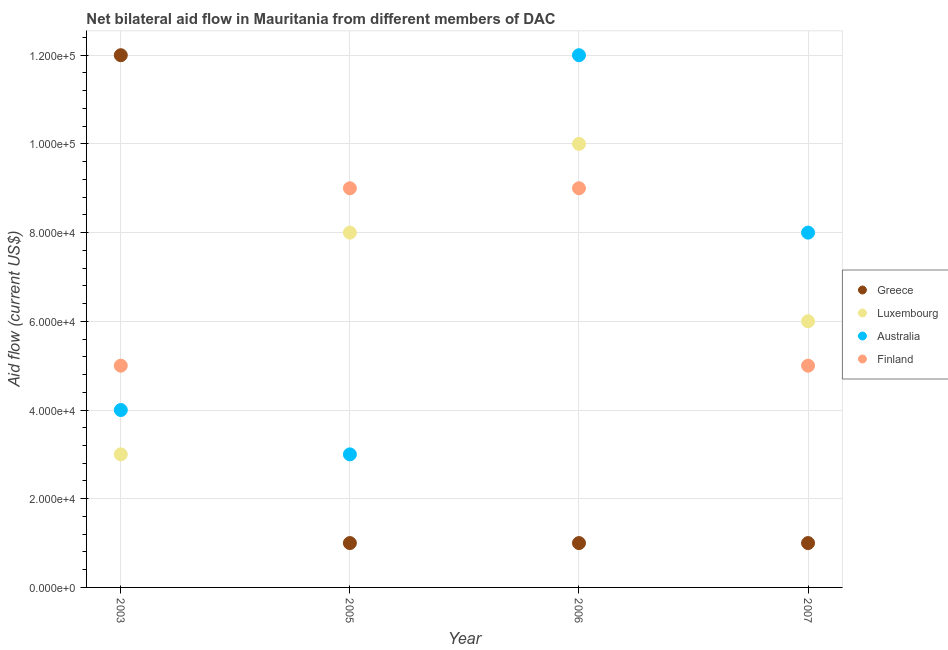How many different coloured dotlines are there?
Offer a terse response. 4. Is the number of dotlines equal to the number of legend labels?
Your response must be concise. Yes. What is the amount of aid given by australia in 2005?
Ensure brevity in your answer.  3.00e+04. Across all years, what is the maximum amount of aid given by finland?
Offer a very short reply. 9.00e+04. Across all years, what is the minimum amount of aid given by australia?
Your answer should be compact. 3.00e+04. In which year was the amount of aid given by australia maximum?
Your answer should be very brief. 2006. In which year was the amount of aid given by finland minimum?
Offer a terse response. 2003. What is the total amount of aid given by australia in the graph?
Offer a very short reply. 2.70e+05. What is the difference between the amount of aid given by finland in 2003 and that in 2005?
Provide a short and direct response. -4.00e+04. What is the difference between the amount of aid given by australia in 2003 and the amount of aid given by luxembourg in 2007?
Your response must be concise. -2.00e+04. What is the average amount of aid given by luxembourg per year?
Keep it short and to the point. 6.75e+04. In the year 2007, what is the difference between the amount of aid given by greece and amount of aid given by luxembourg?
Offer a very short reply. -5.00e+04. Is the difference between the amount of aid given by finland in 2003 and 2006 greater than the difference between the amount of aid given by australia in 2003 and 2006?
Your answer should be very brief. Yes. What is the difference between the highest and the lowest amount of aid given by finland?
Give a very brief answer. 4.00e+04. In how many years, is the amount of aid given by greece greater than the average amount of aid given by greece taken over all years?
Your response must be concise. 1. Is the sum of the amount of aid given by australia in 2003 and 2005 greater than the maximum amount of aid given by greece across all years?
Your answer should be very brief. No. Is it the case that in every year, the sum of the amount of aid given by greece and amount of aid given by luxembourg is greater than the amount of aid given by australia?
Your answer should be compact. No. Is the amount of aid given by greece strictly less than the amount of aid given by australia over the years?
Offer a terse response. No. How many dotlines are there?
Provide a short and direct response. 4. What is the difference between two consecutive major ticks on the Y-axis?
Offer a very short reply. 2.00e+04. How many legend labels are there?
Ensure brevity in your answer.  4. How are the legend labels stacked?
Your answer should be compact. Vertical. What is the title of the graph?
Keep it short and to the point. Net bilateral aid flow in Mauritania from different members of DAC. What is the label or title of the Y-axis?
Provide a succinct answer. Aid flow (current US$). What is the Aid flow (current US$) in Finland in 2003?
Give a very brief answer. 5.00e+04. What is the Aid flow (current US$) of Greece in 2005?
Your answer should be compact. 10000. What is the Aid flow (current US$) of Luxembourg in 2005?
Give a very brief answer. 8.00e+04. What is the Aid flow (current US$) in Australia in 2005?
Keep it short and to the point. 3.00e+04. What is the Aid flow (current US$) in Finland in 2005?
Ensure brevity in your answer.  9.00e+04. What is the Aid flow (current US$) of Greece in 2006?
Ensure brevity in your answer.  10000. What is the Aid flow (current US$) in Luxembourg in 2006?
Ensure brevity in your answer.  1.00e+05. What is the Aid flow (current US$) of Australia in 2006?
Your response must be concise. 1.20e+05. What is the Aid flow (current US$) of Finland in 2006?
Provide a short and direct response. 9.00e+04. What is the Aid flow (current US$) of Luxembourg in 2007?
Provide a succinct answer. 6.00e+04. What is the Aid flow (current US$) of Finland in 2007?
Your answer should be very brief. 5.00e+04. Across all years, what is the maximum Aid flow (current US$) in Luxembourg?
Ensure brevity in your answer.  1.00e+05. Across all years, what is the maximum Aid flow (current US$) of Australia?
Offer a very short reply. 1.20e+05. Across all years, what is the minimum Aid flow (current US$) in Greece?
Provide a succinct answer. 10000. Across all years, what is the minimum Aid flow (current US$) of Australia?
Provide a short and direct response. 3.00e+04. What is the total Aid flow (current US$) of Greece in the graph?
Your answer should be compact. 1.50e+05. What is the total Aid flow (current US$) of Luxembourg in the graph?
Make the answer very short. 2.70e+05. What is the total Aid flow (current US$) of Australia in the graph?
Keep it short and to the point. 2.70e+05. What is the difference between the Aid flow (current US$) of Greece in 2003 and that in 2005?
Offer a very short reply. 1.10e+05. What is the difference between the Aid flow (current US$) of Luxembourg in 2003 and that in 2005?
Keep it short and to the point. -5.00e+04. What is the difference between the Aid flow (current US$) in Australia in 2003 and that in 2005?
Keep it short and to the point. 10000. What is the difference between the Aid flow (current US$) of Finland in 2003 and that in 2005?
Ensure brevity in your answer.  -4.00e+04. What is the difference between the Aid flow (current US$) in Greece in 2003 and that in 2007?
Provide a succinct answer. 1.10e+05. What is the difference between the Aid flow (current US$) of Finland in 2003 and that in 2007?
Your answer should be compact. 0. What is the difference between the Aid flow (current US$) of Greece in 2005 and that in 2006?
Ensure brevity in your answer.  0. What is the difference between the Aid flow (current US$) in Greece in 2005 and that in 2007?
Your answer should be compact. 0. What is the difference between the Aid flow (current US$) in Luxembourg in 2005 and that in 2007?
Make the answer very short. 2.00e+04. What is the difference between the Aid flow (current US$) in Greece in 2003 and the Aid flow (current US$) in Luxembourg in 2005?
Your answer should be very brief. 4.00e+04. What is the difference between the Aid flow (current US$) of Greece in 2003 and the Aid flow (current US$) of Australia in 2005?
Your answer should be very brief. 9.00e+04. What is the difference between the Aid flow (current US$) in Luxembourg in 2003 and the Aid flow (current US$) in Finland in 2005?
Give a very brief answer. -6.00e+04. What is the difference between the Aid flow (current US$) in Greece in 2003 and the Aid flow (current US$) in Luxembourg in 2006?
Offer a very short reply. 2.00e+04. What is the difference between the Aid flow (current US$) of Greece in 2003 and the Aid flow (current US$) of Australia in 2006?
Ensure brevity in your answer.  0. What is the difference between the Aid flow (current US$) in Greece in 2003 and the Aid flow (current US$) in Finland in 2006?
Keep it short and to the point. 3.00e+04. What is the difference between the Aid flow (current US$) of Luxembourg in 2003 and the Aid flow (current US$) of Australia in 2006?
Provide a succinct answer. -9.00e+04. What is the difference between the Aid flow (current US$) of Greece in 2003 and the Aid flow (current US$) of Finland in 2007?
Your response must be concise. 7.00e+04. What is the difference between the Aid flow (current US$) of Luxembourg in 2003 and the Aid flow (current US$) of Australia in 2007?
Give a very brief answer. -5.00e+04. What is the difference between the Aid flow (current US$) of Greece in 2005 and the Aid flow (current US$) of Finland in 2006?
Ensure brevity in your answer.  -8.00e+04. What is the difference between the Aid flow (current US$) in Luxembourg in 2005 and the Aid flow (current US$) in Australia in 2006?
Provide a succinct answer. -4.00e+04. What is the difference between the Aid flow (current US$) in Luxembourg in 2005 and the Aid flow (current US$) in Finland in 2006?
Offer a terse response. -10000. What is the difference between the Aid flow (current US$) in Greece in 2005 and the Aid flow (current US$) in Luxembourg in 2007?
Provide a short and direct response. -5.00e+04. What is the difference between the Aid flow (current US$) in Luxembourg in 2005 and the Aid flow (current US$) in Australia in 2007?
Keep it short and to the point. 0. What is the difference between the Aid flow (current US$) in Australia in 2005 and the Aid flow (current US$) in Finland in 2007?
Give a very brief answer. -2.00e+04. What is the difference between the Aid flow (current US$) in Greece in 2006 and the Aid flow (current US$) in Luxembourg in 2007?
Your answer should be very brief. -5.00e+04. What is the difference between the Aid flow (current US$) of Greece in 2006 and the Aid flow (current US$) of Australia in 2007?
Offer a very short reply. -7.00e+04. What is the difference between the Aid flow (current US$) of Luxembourg in 2006 and the Aid flow (current US$) of Australia in 2007?
Your response must be concise. 2.00e+04. What is the difference between the Aid flow (current US$) in Australia in 2006 and the Aid flow (current US$) in Finland in 2007?
Your answer should be very brief. 7.00e+04. What is the average Aid flow (current US$) in Greece per year?
Offer a terse response. 3.75e+04. What is the average Aid flow (current US$) of Luxembourg per year?
Provide a short and direct response. 6.75e+04. What is the average Aid flow (current US$) of Australia per year?
Make the answer very short. 6.75e+04. What is the average Aid flow (current US$) of Finland per year?
Keep it short and to the point. 7.00e+04. In the year 2003, what is the difference between the Aid flow (current US$) in Greece and Aid flow (current US$) in Luxembourg?
Offer a very short reply. 9.00e+04. In the year 2003, what is the difference between the Aid flow (current US$) in Greece and Aid flow (current US$) in Australia?
Ensure brevity in your answer.  8.00e+04. In the year 2005, what is the difference between the Aid flow (current US$) in Greece and Aid flow (current US$) in Luxembourg?
Give a very brief answer. -7.00e+04. In the year 2005, what is the difference between the Aid flow (current US$) of Greece and Aid flow (current US$) of Australia?
Offer a terse response. -2.00e+04. In the year 2005, what is the difference between the Aid flow (current US$) of Greece and Aid flow (current US$) of Finland?
Give a very brief answer. -8.00e+04. In the year 2005, what is the difference between the Aid flow (current US$) of Luxembourg and Aid flow (current US$) of Australia?
Your answer should be compact. 5.00e+04. In the year 2006, what is the difference between the Aid flow (current US$) in Greece and Aid flow (current US$) in Australia?
Give a very brief answer. -1.10e+05. In the year 2006, what is the difference between the Aid flow (current US$) in Luxembourg and Aid flow (current US$) in Finland?
Your response must be concise. 10000. In the year 2006, what is the difference between the Aid flow (current US$) in Australia and Aid flow (current US$) in Finland?
Ensure brevity in your answer.  3.00e+04. In the year 2007, what is the difference between the Aid flow (current US$) of Greece and Aid flow (current US$) of Luxembourg?
Keep it short and to the point. -5.00e+04. In the year 2007, what is the difference between the Aid flow (current US$) in Greece and Aid flow (current US$) in Finland?
Offer a terse response. -4.00e+04. What is the ratio of the Aid flow (current US$) in Greece in 2003 to that in 2005?
Your answer should be compact. 12. What is the ratio of the Aid flow (current US$) in Luxembourg in 2003 to that in 2005?
Your answer should be very brief. 0.38. What is the ratio of the Aid flow (current US$) in Australia in 2003 to that in 2005?
Your response must be concise. 1.33. What is the ratio of the Aid flow (current US$) in Finland in 2003 to that in 2005?
Provide a short and direct response. 0.56. What is the ratio of the Aid flow (current US$) in Greece in 2003 to that in 2006?
Provide a short and direct response. 12. What is the ratio of the Aid flow (current US$) of Australia in 2003 to that in 2006?
Offer a terse response. 0.33. What is the ratio of the Aid flow (current US$) in Finland in 2003 to that in 2006?
Keep it short and to the point. 0.56. What is the ratio of the Aid flow (current US$) of Luxembourg in 2003 to that in 2007?
Ensure brevity in your answer.  0.5. What is the ratio of the Aid flow (current US$) in Australia in 2003 to that in 2007?
Your answer should be very brief. 0.5. What is the ratio of the Aid flow (current US$) in Finland in 2003 to that in 2007?
Give a very brief answer. 1. What is the ratio of the Aid flow (current US$) in Greece in 2005 to that in 2006?
Provide a succinct answer. 1. What is the ratio of the Aid flow (current US$) in Luxembourg in 2005 to that in 2006?
Give a very brief answer. 0.8. What is the ratio of the Aid flow (current US$) in Finland in 2005 to that in 2007?
Your response must be concise. 1.8. What is the ratio of the Aid flow (current US$) of Greece in 2006 to that in 2007?
Provide a short and direct response. 1. What is the ratio of the Aid flow (current US$) in Luxembourg in 2006 to that in 2007?
Provide a short and direct response. 1.67. What is the ratio of the Aid flow (current US$) of Australia in 2006 to that in 2007?
Your response must be concise. 1.5. What is the difference between the highest and the second highest Aid flow (current US$) of Greece?
Offer a terse response. 1.10e+05. What is the difference between the highest and the second highest Aid flow (current US$) of Luxembourg?
Give a very brief answer. 2.00e+04. What is the difference between the highest and the second highest Aid flow (current US$) of Australia?
Give a very brief answer. 4.00e+04. What is the difference between the highest and the second highest Aid flow (current US$) of Finland?
Your answer should be compact. 0. What is the difference between the highest and the lowest Aid flow (current US$) in Luxembourg?
Make the answer very short. 7.00e+04. What is the difference between the highest and the lowest Aid flow (current US$) of Finland?
Make the answer very short. 4.00e+04. 